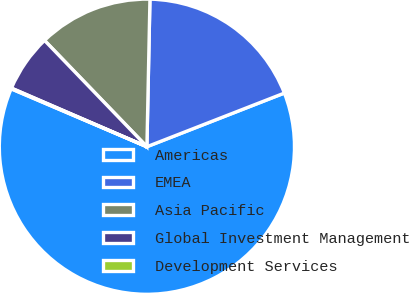Convert chart to OTSL. <chart><loc_0><loc_0><loc_500><loc_500><pie_chart><fcel>Americas<fcel>EMEA<fcel>Asia Pacific<fcel>Global Investment Management<fcel>Development Services<nl><fcel>62.34%<fcel>18.75%<fcel>12.53%<fcel>6.3%<fcel>0.08%<nl></chart> 